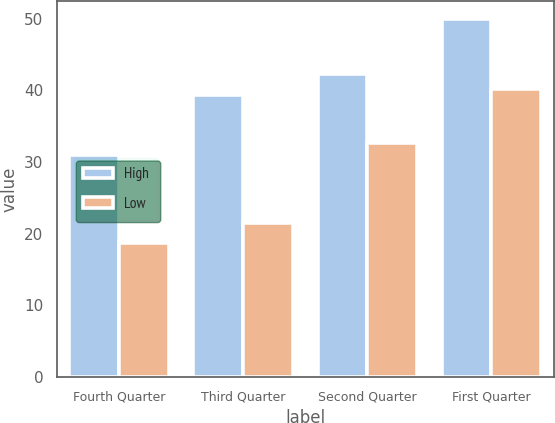Convert chart. <chart><loc_0><loc_0><loc_500><loc_500><stacked_bar_chart><ecel><fcel>Fourth Quarter<fcel>Third Quarter<fcel>Second Quarter<fcel>First Quarter<nl><fcel>High<fcel>30.99<fcel>39.43<fcel>42.3<fcel>49.99<nl><fcel>Low<fcel>18.7<fcel>21.5<fcel>32.68<fcel>40.26<nl></chart> 